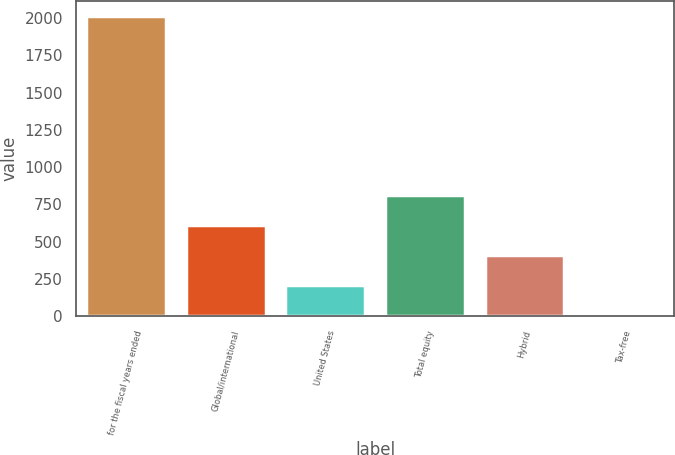<chart> <loc_0><loc_0><loc_500><loc_500><bar_chart><fcel>for the fiscal years ended<fcel>Global/international<fcel>United States<fcel>Total equity<fcel>Hybrid<fcel>Tax-free<nl><fcel>2014<fcel>609.8<fcel>208.6<fcel>810.4<fcel>409.2<fcel>8<nl></chart> 